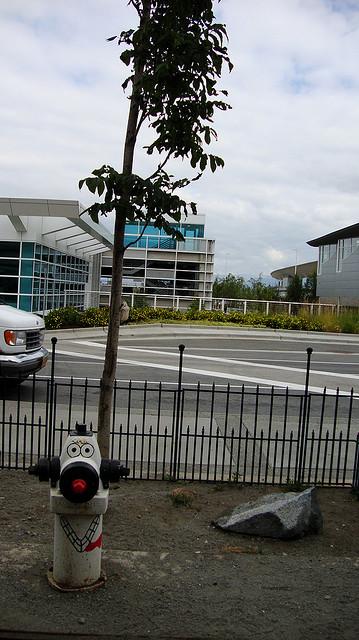What color is the fire hydrant?
Be succinct. White. Is the building in the far left a modern architectural design?
Answer briefly. Yes. What color are the rails?
Be succinct. Black. What is laying next to the fire hydrant?
Keep it brief. Rock. Would this fence be easy to climb over?
Concise answer only. Yes. Is the fence high?
Be succinct. No. Could you get a good sun tan in this sort of weather?
Quick response, please. No. What is the fire hydrant painted like?
Be succinct. Dog. 